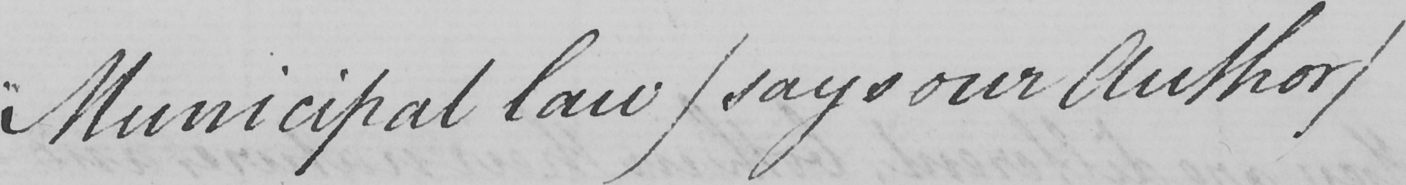Please transcribe the handwritten text in this image. [  " Municipal law  ( says our Author ) 